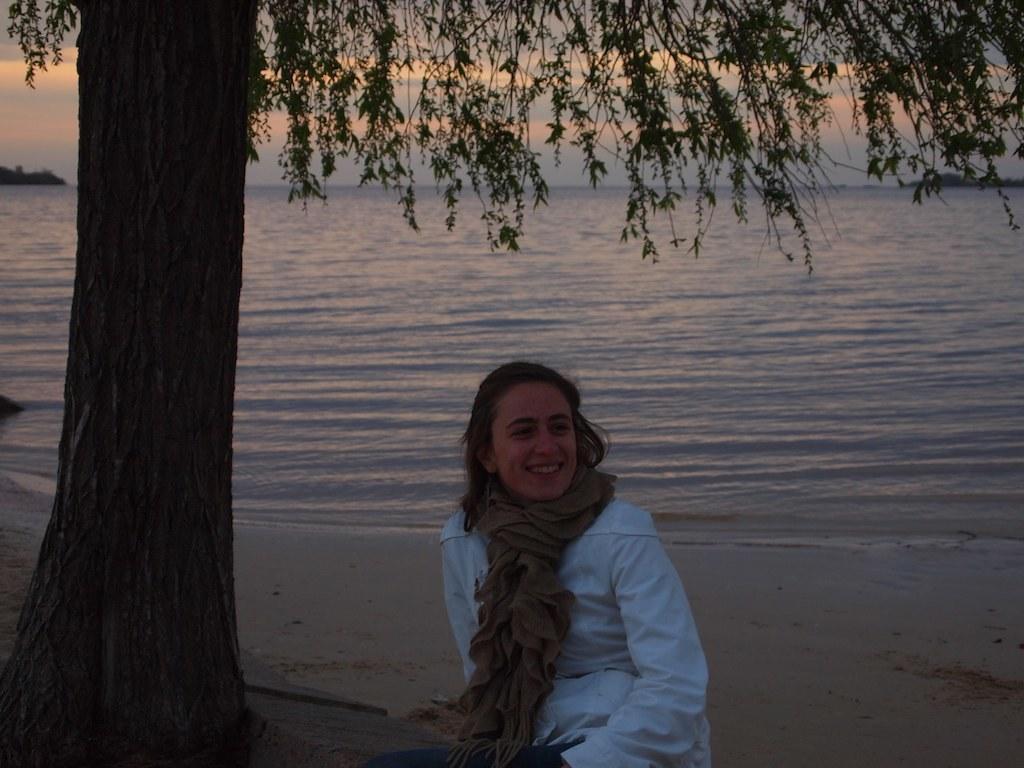Please provide a concise description of this image. This is the picture of a sea. In this image there is a person sitting and smiling. On the left side of the image there is a tree. At the back there is water. At the top there is sky and there are clouds. At the bottom there is sand. 